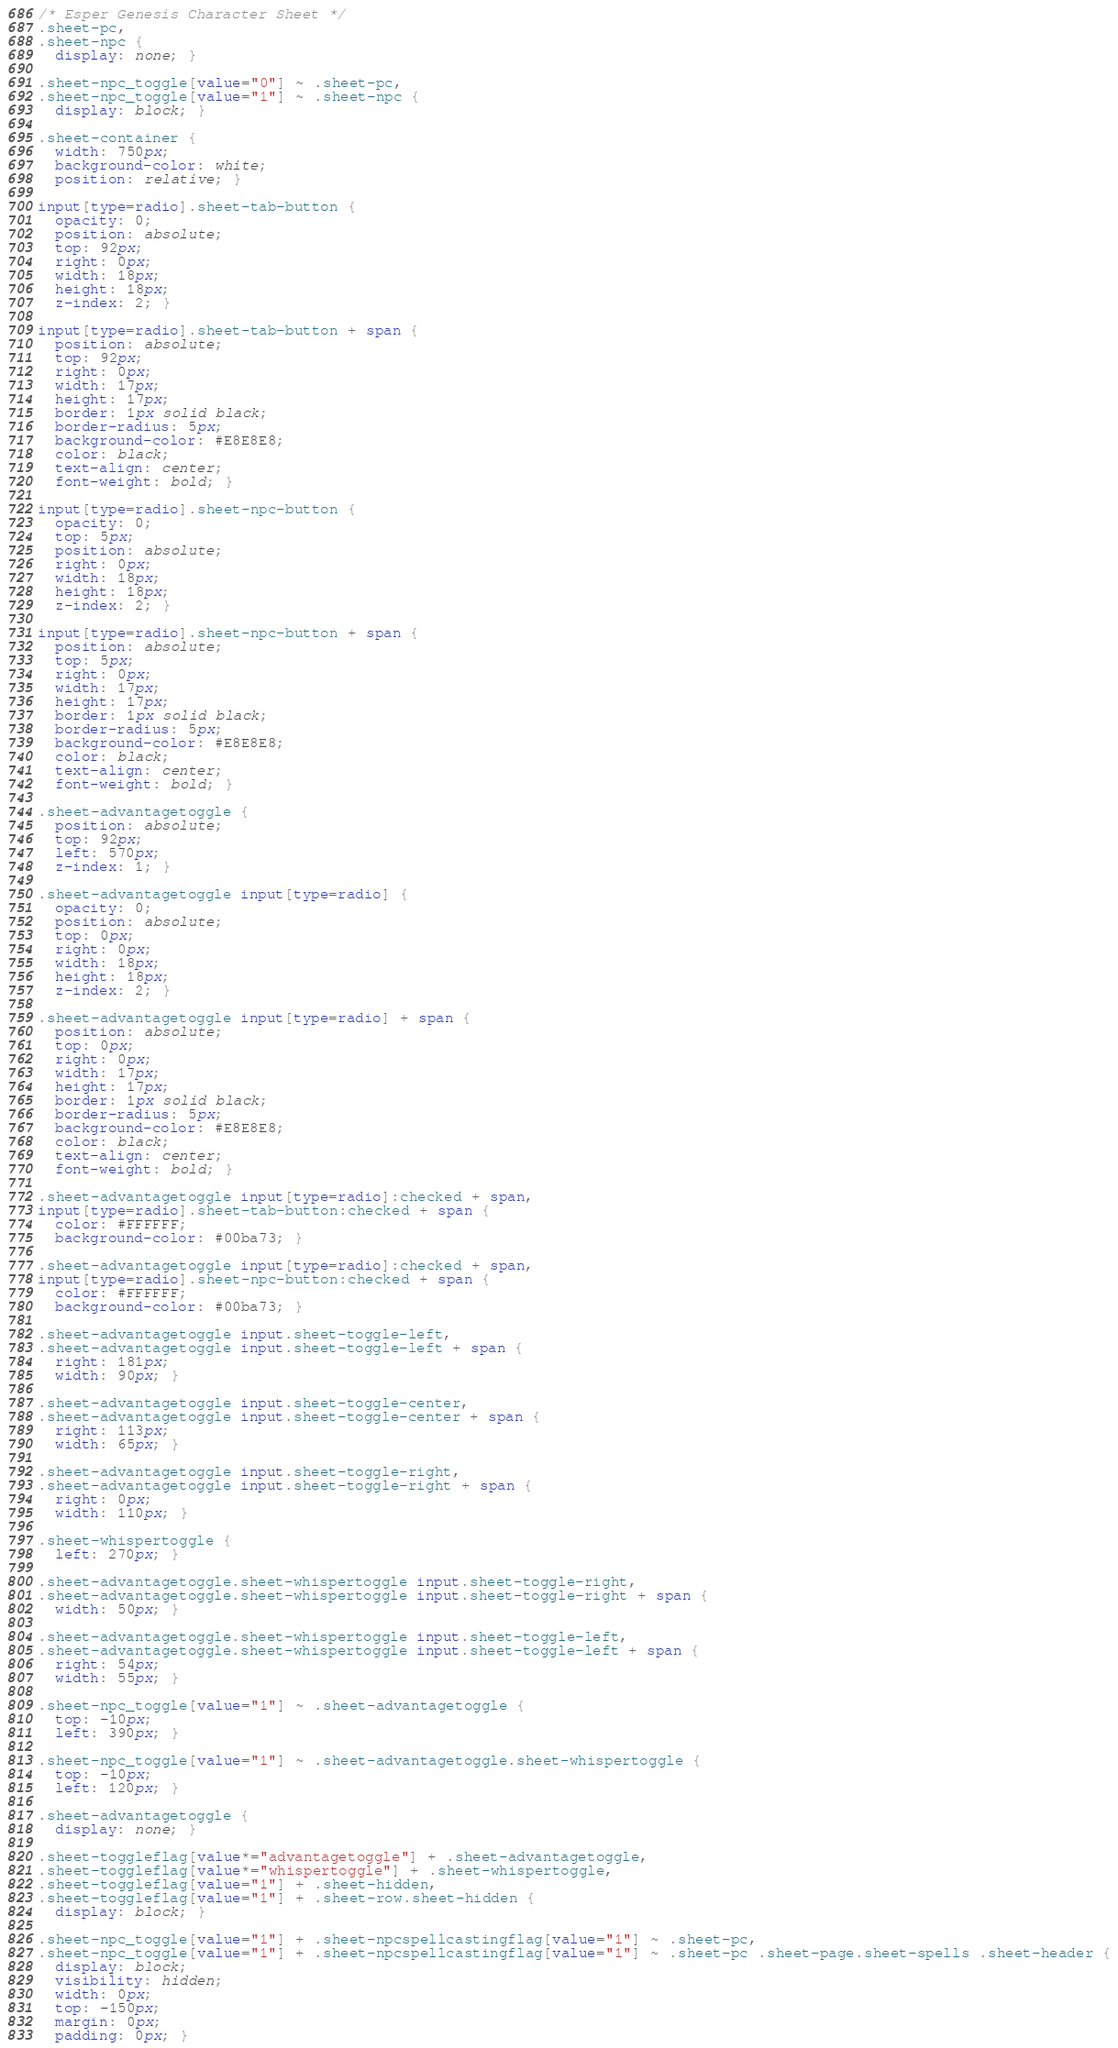<code> <loc_0><loc_0><loc_500><loc_500><_CSS_>/* Esper Genesis Character Sheet */
.sheet-pc,
.sheet-npc {
  display: none; }

.sheet-npc_toggle[value="0"] ~ .sheet-pc,
.sheet-npc_toggle[value="1"] ~ .sheet-npc {
  display: block; }

.sheet-container {
  width: 750px;
  background-color: white;
  position: relative; }

input[type=radio].sheet-tab-button {
  opacity: 0;
  position: absolute;
  top: 92px;
  right: 0px;
  width: 18px;
  height: 18px;
  z-index: 2; }

input[type=radio].sheet-tab-button + span {
  position: absolute;
  top: 92px;
  right: 0px;
  width: 17px;
  height: 17px;
  border: 1px solid black;
  border-radius: 5px;
  background-color: #E8E8E8;
  color: black;
  text-align: center;
  font-weight: bold; }

input[type=radio].sheet-npc-button {
  opacity: 0;
  top: 5px;
  position: absolute;
  right: 0px;
  width: 18px;
  height: 18px;
  z-index: 2; }

input[type=radio].sheet-npc-button + span {
  position: absolute;
  top: 5px;
  right: 0px;
  width: 17px;
  height: 17px;
  border: 1px solid black;
  border-radius: 5px;
  background-color: #E8E8E8;
  color: black;
  text-align: center;
  font-weight: bold; }

.sheet-advantagetoggle {
  position: absolute;
  top: 92px;
  left: 570px;
  z-index: 1; }

.sheet-advantagetoggle input[type=radio] {
  opacity: 0;
  position: absolute;
  top: 0px;
  right: 0px;
  width: 18px;
  height: 18px;
  z-index: 2; }

.sheet-advantagetoggle input[type=radio] + span {
  position: absolute;
  top: 0px;
  right: 0px;
  width: 17px;
  height: 17px;
  border: 1px solid black;
  border-radius: 5px;
  background-color: #E8E8E8;
  color: black;
  text-align: center;
  font-weight: bold; }

.sheet-advantagetoggle input[type=radio]:checked + span,
input[type=radio].sheet-tab-button:checked + span {
  color: #FFFFFF;
  background-color: #00ba73; }

.sheet-advantagetoggle input[type=radio]:checked + span,
input[type=radio].sheet-npc-button:checked + span {
  color: #FFFFFF;
  background-color: #00ba73; }

.sheet-advantagetoggle input.sheet-toggle-left,
.sheet-advantagetoggle input.sheet-toggle-left + span {
  right: 181px;
  width: 90px; }

.sheet-advantagetoggle input.sheet-toggle-center,
.sheet-advantagetoggle input.sheet-toggle-center + span {
  right: 113px;
  width: 65px; }

.sheet-advantagetoggle input.sheet-toggle-right,
.sheet-advantagetoggle input.sheet-toggle-right + span {
  right: 0px;
  width: 110px; }

.sheet-whispertoggle {
  left: 270px; }

.sheet-advantagetoggle.sheet-whispertoggle input.sheet-toggle-right,
.sheet-advantagetoggle.sheet-whispertoggle input.sheet-toggle-right + span {
  width: 50px; }

.sheet-advantagetoggle.sheet-whispertoggle input.sheet-toggle-left,
.sheet-advantagetoggle.sheet-whispertoggle input.sheet-toggle-left + span {
  right: 54px;
  width: 55px; }

.sheet-npc_toggle[value="1"] ~ .sheet-advantagetoggle {
  top: -10px;
  left: 390px; }

.sheet-npc_toggle[value="1"] ~ .sheet-advantagetoggle.sheet-whispertoggle {
  top: -10px;
  left: 120px; }

.sheet-advantagetoggle {
  display: none; }

.sheet-toggleflag[value*="advantagetoggle"] + .sheet-advantagetoggle,
.sheet-toggleflag[value*="whispertoggle"] + .sheet-whispertoggle,
.sheet-toggleflag[value="1"] + .sheet-hidden,
.sheet-toggleflag[value="1"] + .sheet-row.sheet-hidden {
  display: block; }

.sheet-npc_toggle[value="1"] + .sheet-npcspellcastingflag[value="1"] ~ .sheet-pc,
.sheet-npc_toggle[value="1"] + .sheet-npcspellcastingflag[value="1"] ~ .sheet-pc .sheet-page.sheet-spells .sheet-header {
  display: block;
  visibility: hidden;
  width: 0px;
  top: -150px;
  margin: 0px;
  padding: 0px; }
</code> 